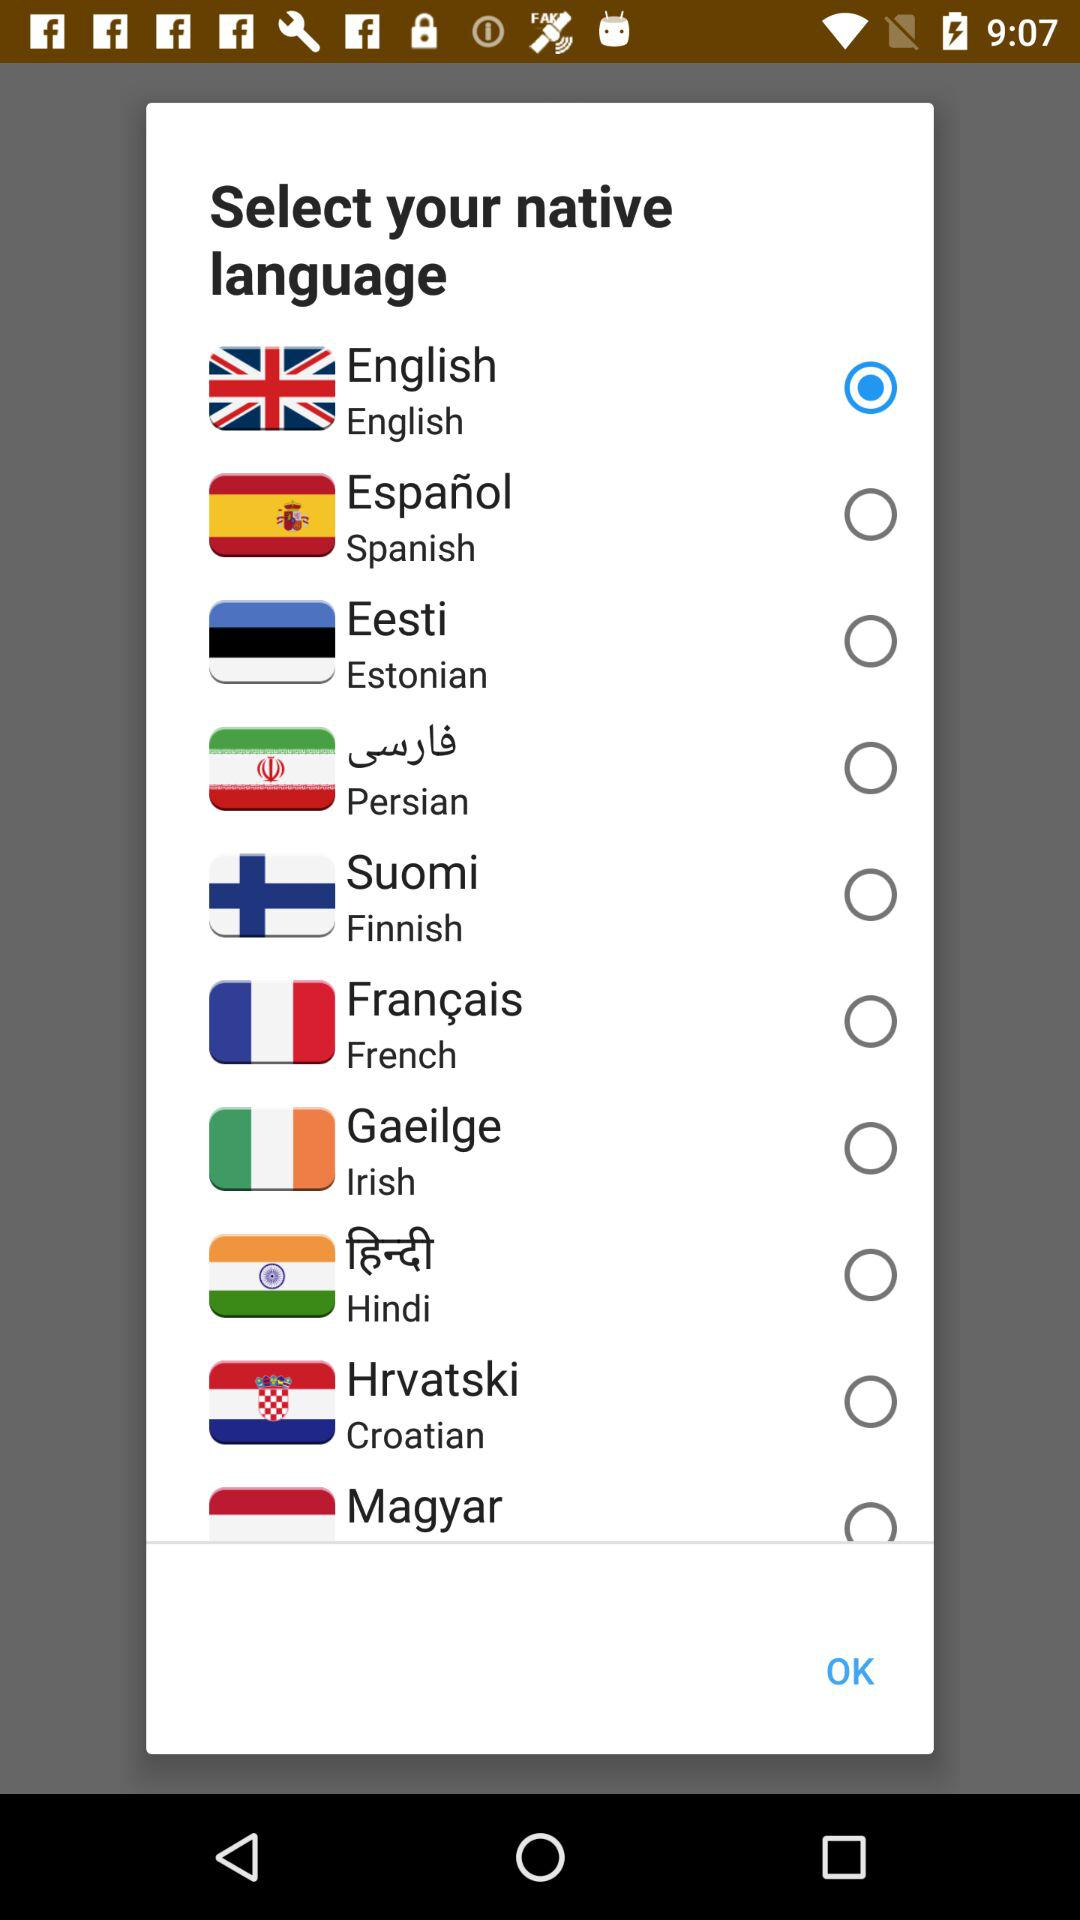Which native language is selected? The selected native language is English. 